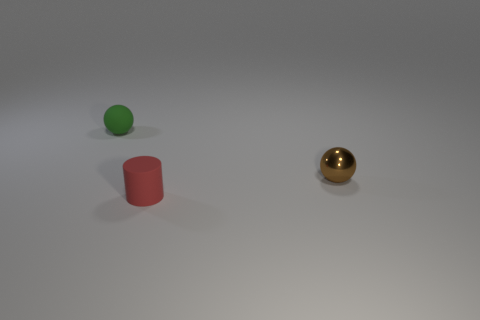Are there any other things that have the same material as the small brown thing?
Provide a succinct answer. No. How many small red cylinders are in front of the tiny ball behind the sphere to the right of the green object?
Your answer should be compact. 1. There is a tiny rubber thing that is behind the matte cylinder; is its shape the same as the thing to the right of the red rubber thing?
Provide a succinct answer. Yes. How many things are big cyan metal things or brown spheres?
Keep it short and to the point. 1. What material is the cylinder in front of the tiny ball to the left of the tiny red rubber cylinder?
Give a very brief answer. Rubber. Is there a metallic thing that has the same color as the rubber cylinder?
Provide a short and direct response. No. There is a cylinder that is the same size as the brown shiny object; what color is it?
Your answer should be very brief. Red. What material is the ball that is to the left of the tiny red thing in front of the sphere that is to the left of the tiny cylinder?
Provide a short and direct response. Rubber. How many objects are objects that are left of the tiny brown metallic ball or small matte objects that are in front of the green sphere?
Keep it short and to the point. 2. What shape is the matte thing that is in front of the thing to the left of the tiny rubber cylinder?
Your response must be concise. Cylinder. 